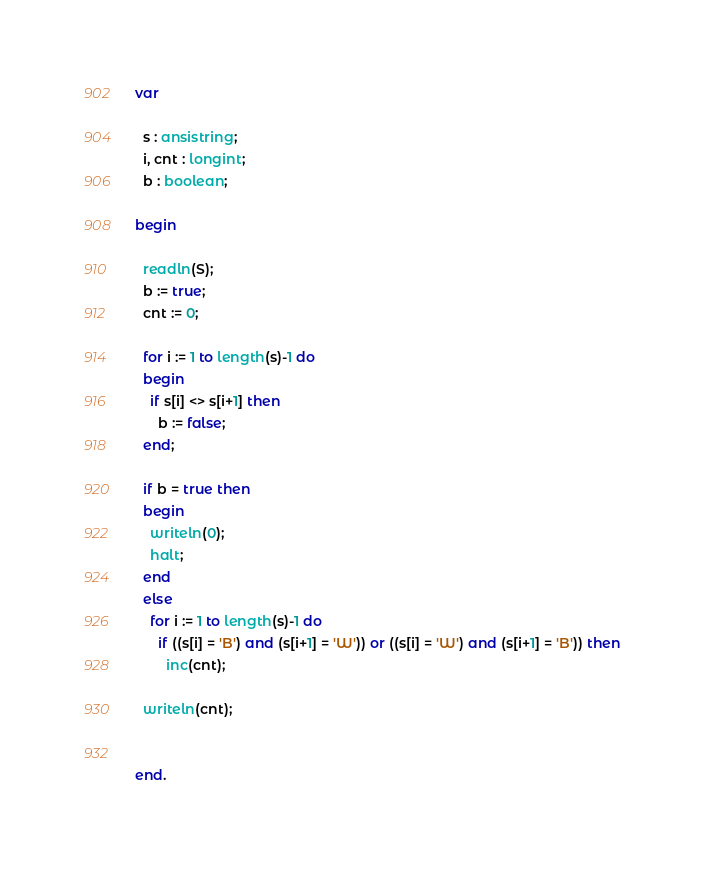<code> <loc_0><loc_0><loc_500><loc_500><_Pascal_>var

  s : ansistring;
  i, cnt : longint;
  b : boolean;
  
begin

  readln(S);
  b := true;
  cnt := 0;
  
  for i := 1 to length(s)-1 do
  begin
    if s[i] <> s[i+1] then
      b := false;
  end;
  
  if b = true then
  begin
    writeln(0);
    halt;
  end
  else
    for i := 1 to length(s)-1 do
      if ((s[i] = 'B') and (s[i+1] = 'W')) or ((s[i] = 'W') and (s[i+1] = 'B')) then
        inc(cnt);
        
  writeln(cnt);
  

end.</code> 